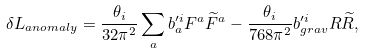<formula> <loc_0><loc_0><loc_500><loc_500>\delta L _ { a n o m a l y } = \frac { \theta _ { i } } { 3 2 \pi ^ { 2 } } \sum _ { a } b _ { a } ^ { \prime i } F ^ { a } \widetilde { F } ^ { a } - \frac { \theta _ { i } } { 7 6 8 \pi ^ { 2 } } b _ { g r a v } ^ { \prime i } R \widetilde { R } ,</formula> 